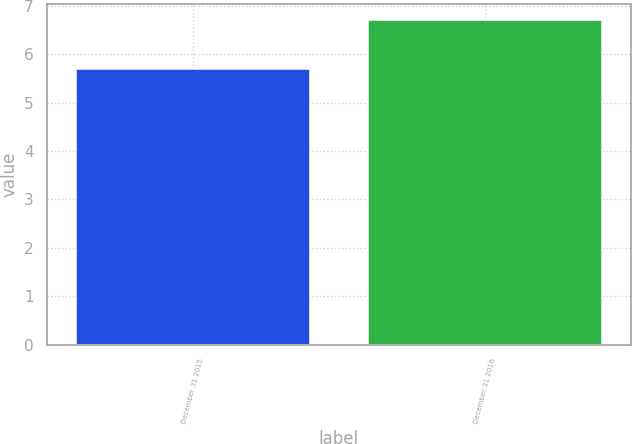Convert chart to OTSL. <chart><loc_0><loc_0><loc_500><loc_500><bar_chart><fcel>December 31 2015<fcel>December 31 2016<nl><fcel>5.7<fcel>6.7<nl></chart> 